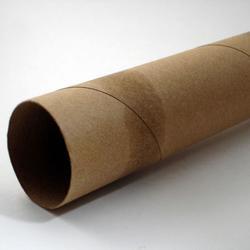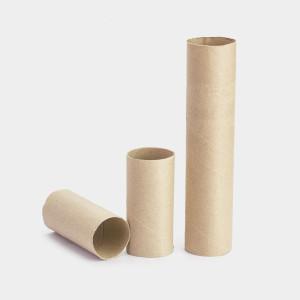The first image is the image on the left, the second image is the image on the right. Given the left and right images, does the statement "All these images contain paper towels standing upright on their rolls." hold true? Answer yes or no. No. 